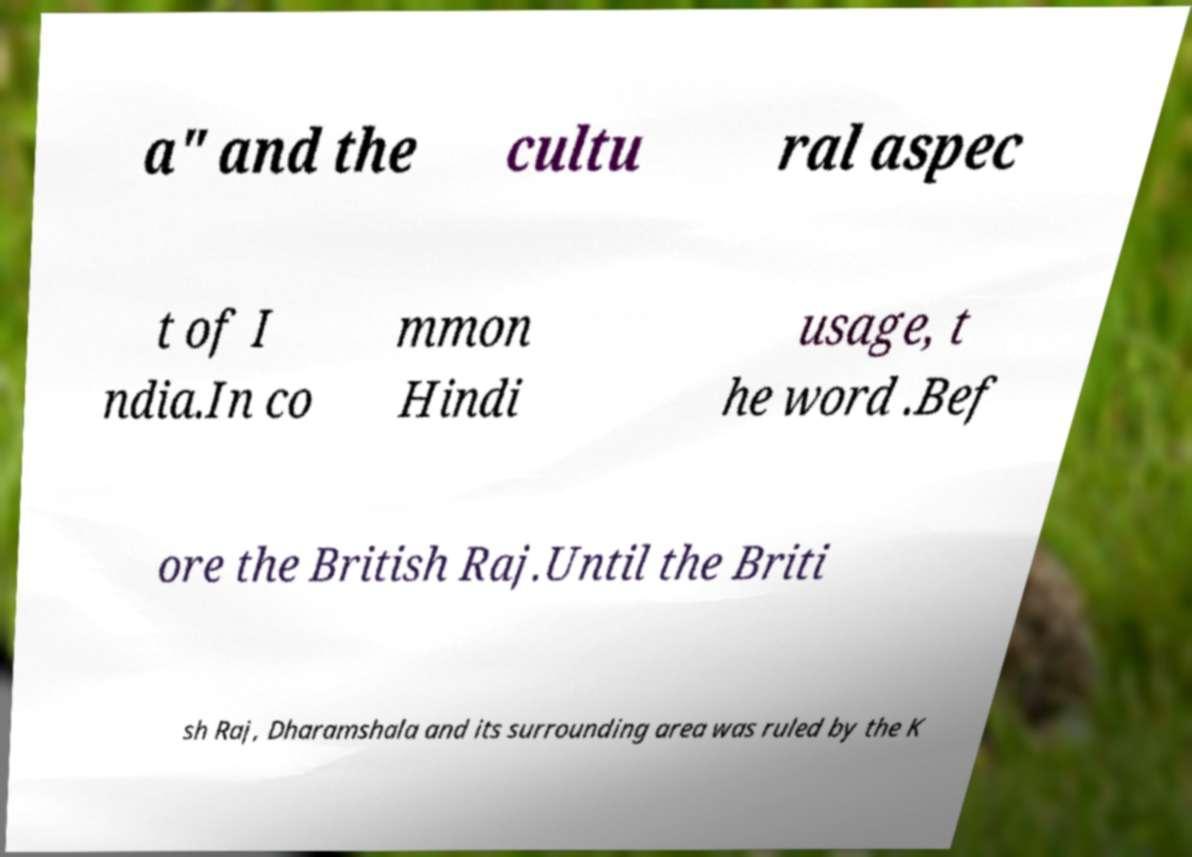Please read and relay the text visible in this image. What does it say? a" and the cultu ral aspec t of I ndia.In co mmon Hindi usage, t he word .Bef ore the British Raj.Until the Briti sh Raj, Dharamshala and its surrounding area was ruled by the K 